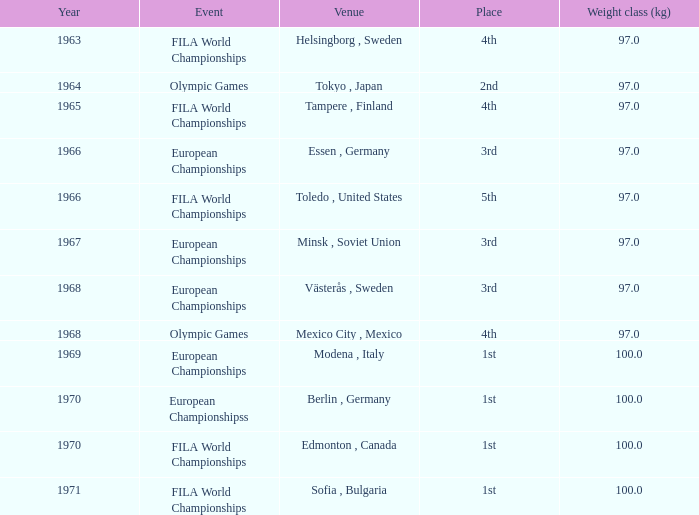What is the smallest weight division (kg) featuring sofia, bulgaria as the site? 100.0. 